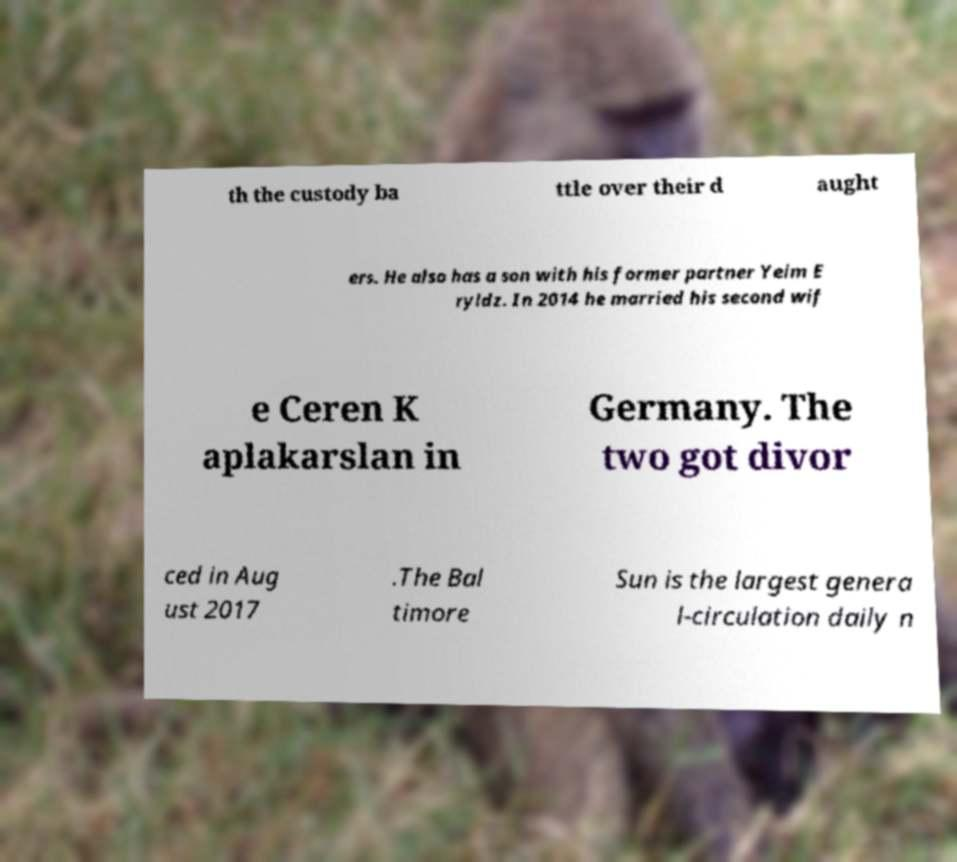Please read and relay the text visible in this image. What does it say? th the custody ba ttle over their d aught ers. He also has a son with his former partner Yeim E ryldz. In 2014 he married his second wif e Ceren K aplakarslan in Germany. The two got divor ced in Aug ust 2017 .The Bal timore Sun is the largest genera l-circulation daily n 